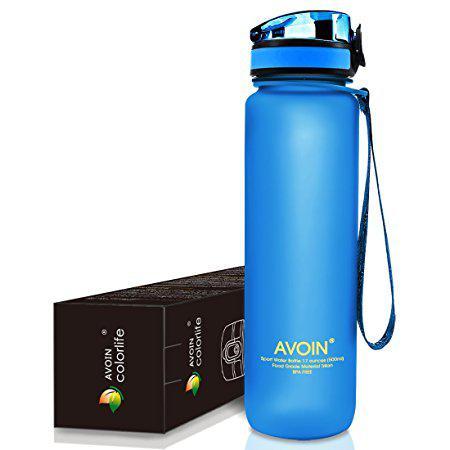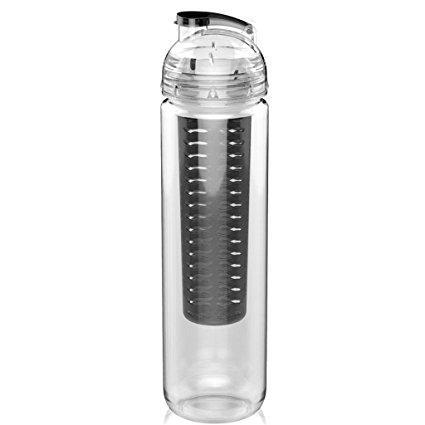The first image is the image on the left, the second image is the image on the right. Analyze the images presented: Is the assertion "There is a single closed bottle in the right image." valid? Answer yes or no. Yes. The first image is the image on the left, the second image is the image on the right. Assess this claim about the two images: "At least one of the water bottles has other objects next to it.". Correct or not? Answer yes or no. Yes. 